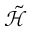Convert formula to latex. <formula><loc_0><loc_0><loc_500><loc_500>\tilde { \mathcal { H } }</formula> 